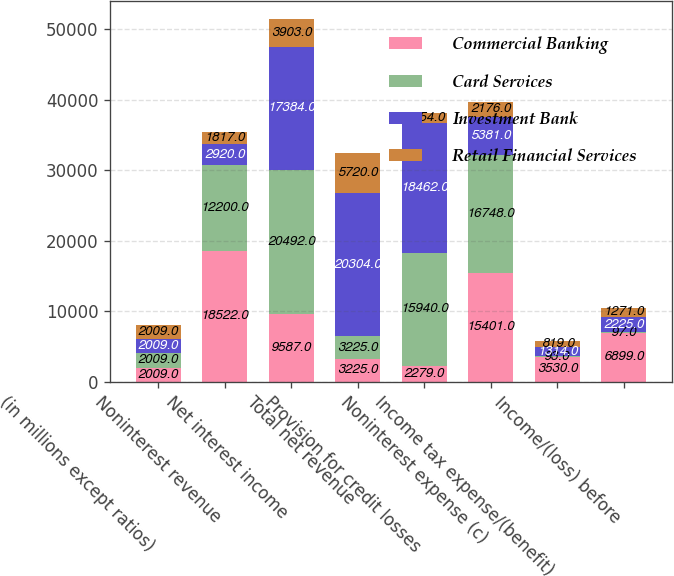Convert chart. <chart><loc_0><loc_0><loc_500><loc_500><stacked_bar_chart><ecel><fcel>(in millions except ratios)<fcel>Noninterest revenue<fcel>Net interest income<fcel>Total net revenue<fcel>Provision for credit losses<fcel>Noninterest expense (c)<fcel>Income tax expense/(benefit)<fcel>Income/(loss) before<nl><fcel>Commercial Banking<fcel>2009<fcel>18522<fcel>9587<fcel>3225<fcel>2279<fcel>15401<fcel>3530<fcel>6899<nl><fcel>Card Services<fcel>2009<fcel>12200<fcel>20492<fcel>3225<fcel>15940<fcel>16748<fcel>93<fcel>97<nl><fcel>Investment Bank<fcel>2009<fcel>2920<fcel>17384<fcel>20304<fcel>18462<fcel>5381<fcel>1314<fcel>2225<nl><fcel>Retail Financial Services<fcel>2009<fcel>1817<fcel>3903<fcel>5720<fcel>1454<fcel>2176<fcel>819<fcel>1271<nl></chart> 